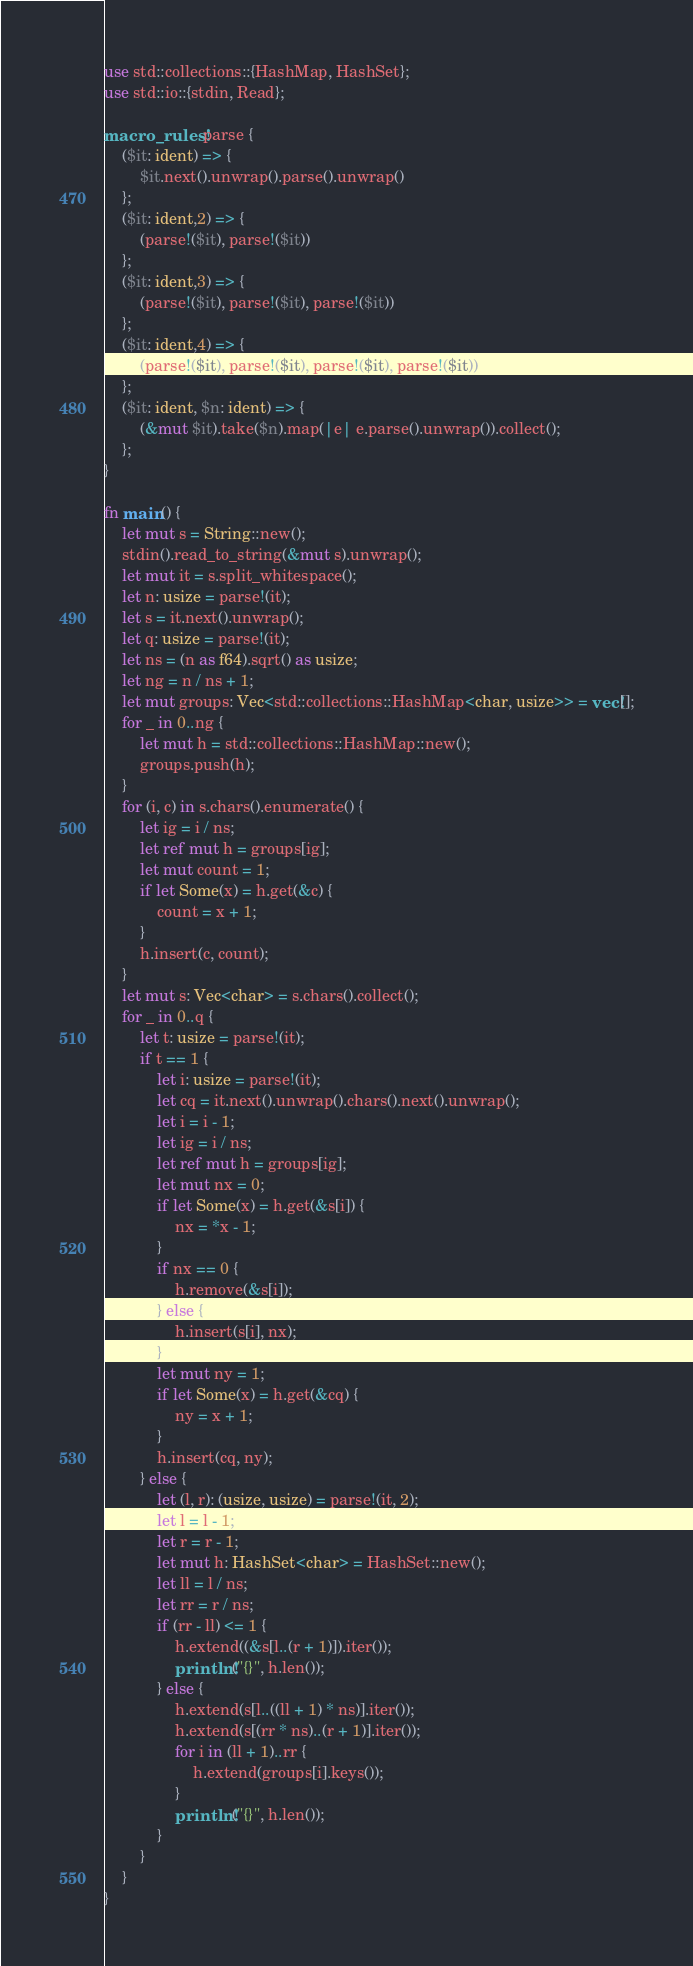<code> <loc_0><loc_0><loc_500><loc_500><_Rust_>use std::collections::{HashMap, HashSet};
use std::io::{stdin, Read};

macro_rules! parse {
    ($it: ident) => {
        $it.next().unwrap().parse().unwrap()
    };
    ($it: ident,2) => {
        (parse!($it), parse!($it))
    };
    ($it: ident,3) => {
        (parse!($it), parse!($it), parse!($it))
    };
    ($it: ident,4) => {
        (parse!($it), parse!($it), parse!($it), parse!($it))
    };
    ($it: ident, $n: ident) => {
        (&mut $it).take($n).map(|e| e.parse().unwrap()).collect();
    };
}

fn main() {
    let mut s = String::new();
    stdin().read_to_string(&mut s).unwrap();
    let mut it = s.split_whitespace();
    let n: usize = parse!(it);
    let s = it.next().unwrap();
    let q: usize = parse!(it);
    let ns = (n as f64).sqrt() as usize;
    let ng = n / ns + 1;
    let mut groups: Vec<std::collections::HashMap<char, usize>> = vec![];
    for _ in 0..ng {
        let mut h = std::collections::HashMap::new();
        groups.push(h);
    }
    for (i, c) in s.chars().enumerate() {
        let ig = i / ns;
        let ref mut h = groups[ig];
        let mut count = 1;
        if let Some(x) = h.get(&c) {
            count = x + 1;
        }
        h.insert(c, count);
    }
    let mut s: Vec<char> = s.chars().collect();
    for _ in 0..q {
        let t: usize = parse!(it);
        if t == 1 {
            let i: usize = parse!(it);
            let cq = it.next().unwrap().chars().next().unwrap();
            let i = i - 1;
            let ig = i / ns;
            let ref mut h = groups[ig];
            let mut nx = 0;
            if let Some(x) = h.get(&s[i]) {
                nx = *x - 1;
            }
            if nx == 0 {
                h.remove(&s[i]);
            } else {
                h.insert(s[i], nx);
            }
            let mut ny = 1;
            if let Some(x) = h.get(&cq) {
                ny = x + 1;
            }
            h.insert(cq, ny);
        } else {
            let (l, r): (usize, usize) = parse!(it, 2);
            let l = l - 1;
            let r = r - 1;
            let mut h: HashSet<char> = HashSet::new();
            let ll = l / ns;
            let rr = r / ns;
            if (rr - ll) <= 1 {
                h.extend((&s[l..(r + 1)]).iter());
                println!("{}", h.len());
            } else {
                h.extend(s[l..((ll + 1) * ns)].iter());
                h.extend(s[(rr * ns)..(r + 1)].iter());
                for i in (ll + 1)..rr {
                    h.extend(groups[i].keys());
                }
                println!("{}", h.len());
            }
        }
    }
}
</code> 